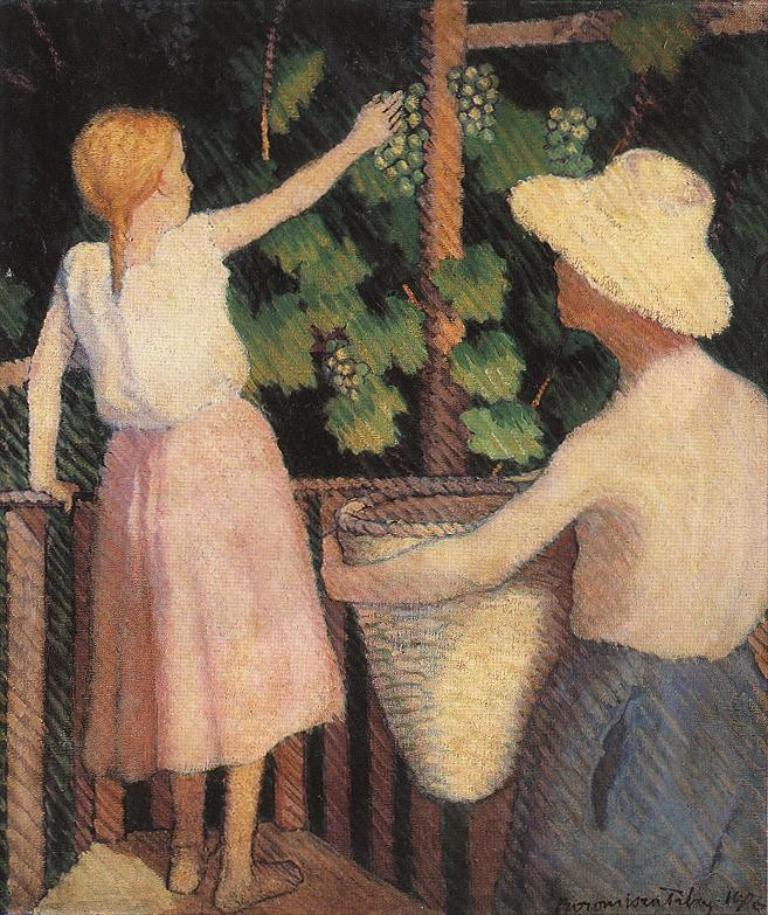What is the main subject of the image? There is a painting in the image. What is depicted in the painting? The painting depicts two people. What are the two people doing in the painting? The two people are standing. What are the two people holding in the painting? The two people are holding objects. What else can be seen in the painting besides the two people? There are other objects present in the painting. What type of sweater is the person on the left wearing in the painting? There is no sweater mentioned or depicted in the painting; the two people are not wearing any clothing. How many ducks are visible in the painting? There are no ducks present in the painting; it only depicts two people and other objects. 